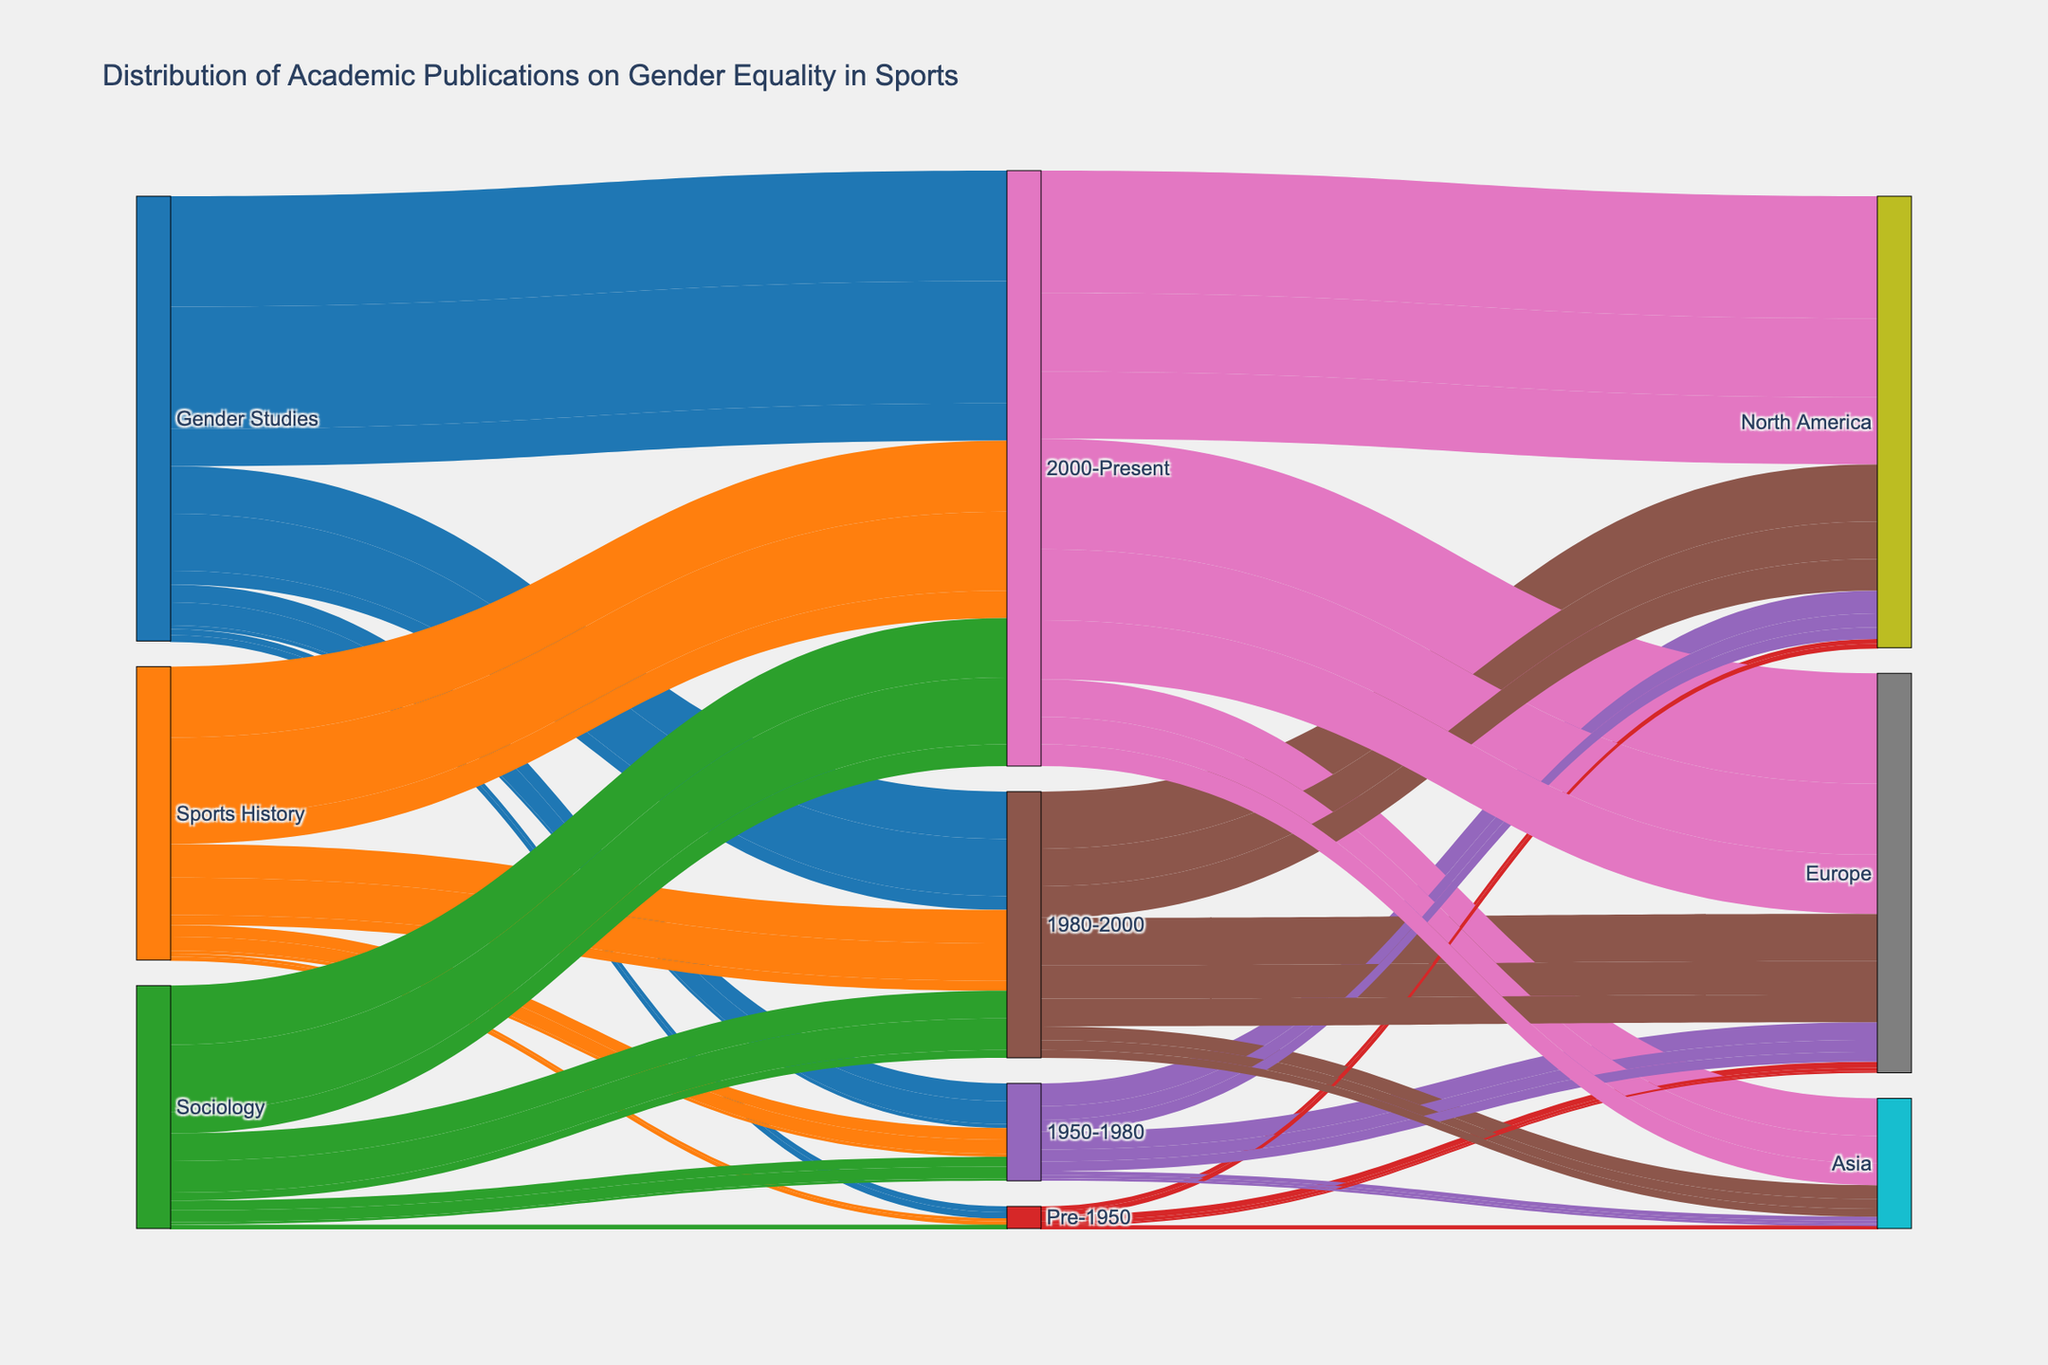what are the three regions shown in the Sankey Diagram? The Sankey Diagram shows connections from different sources to periods and finally to regions. The three regions listed in the diagram are Europe, North America, and Asia.
Answer: Europe, North America, and Asia How many publications were there in the "Gender Studies" category for the period "2000-Present" across all regions? To find the total number of publications for the "Gender Studies" category in the "2000-Present" period, we sum up the values for this category: 280 (Europe) + 310 (North America) + 95 (Asia) = 685.
Answer: 685 Which period has the highest total number of academic publications in "Sports History"? We calculate the total publications in each period for "Sports History": 
- Pre-1950: 8 (Europe) + 6 (North America) + 2 (Asia) = 16
- 1950-1980: 30 (Europe) + 35 (North America) + 8 (Asia) = 73
- 1980-2000: 85 (Europe) + 95 (North America) + 25 (Asia) = 205
- 2000-Present: 180 (Europe) + 200 (North America) + 70 (Asia) = 450 
The period with the highest total is "2000-Present" with a total of 450 publications.
Answer: 2000-Present Between Europe and North America, which region saw more publications in the "Sociology" category during the "1950-1980" period? We compare the number of publications in "Sociology" during "1950-1980". Europe has 25 publications and North America has 30 publications. Therefore, North America saw more publications.
Answer: North America How did the number of "Sports History" publications in Asia change from "Pre-1950" to "2000-Present"? The number of publications in "Sports History" in Asia for each period are: 
- Pre-1950: 2
- 1950-1980: 8
- 1980-2000: 25
- 2000-Present: 70 
The number has increased from 2 (Pre-1950) to 70 (2000-Present).
Answer: Increased by 68 Which category had the highest number of publications in Europe for the period "1980-2000"? To determine this, we compare the number of publications in Europe during the period "1980-2000" across all categories:
- Gender Studies: 120
- Sports History: 85
- Sociology: 70 
The category with the highest number is "Gender Studies" with 120 publications.
Answer: Gender Studies What is the combined total number of publications for "Sociology" across all periods and regions? To determine the combined total for "Sociology" across all periods and regions, we add all the values:
- Pre-1950: 5 (Europe) + 4 (North America) + 1 (Asia) = 10
- 1950-1980: 25 (Europe) + 30 (North America) + 6 (Asia) = 61
- 1980-2000: 70 (Europe) + 80 (North America) + 20 (Asia) = 170
- 2000-Present: 150 (Europe) + 170 (North America) + 55 (Asia) = 375 
The combined total is 10 + 61 + 170 + 375 = 616.
Answer: 616 Which category has the fewest publications in the "Pre-1950" period in North America? We compare the number of publications in North America during the "Pre-1950" period across all categories:
- Gender Studies: 12
- Sports History: 6
- Sociology: 4 
The category with the fewest publications is "Sociology" with 4 publications.
Answer: Sociology How does the "Gender Studies" publication count for Asia in the period "1980-2000" compare to "1950-1980"? From the Sankey Diagram, the number of publications for "Gender Studies" in Asia are:
- 1950-1980: 10
- 1980-2000: 35 
The count increased from 10 to 35, showing an increase of 25 publications.
Answer: Increased by 25 Which period shows the largest difference in the number of publications between "Europe" and "North America" in the "Sports History" category? We calculate the difference for each period:
- Pre-1950: 8 (Europe) - 6 (North America) = 2
- 1950-1980: 30 (Europe) - 35 (North America) = -5
- 1980-2000: 85 (Europe) - 95 (North America) = -10
- 2000-Present: 180 (Europe) - 200 (North America) = -20 
The largest difference in absolute value is -20 during the "2000-Present" period.
Answer: 2000-Present 